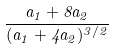<formula> <loc_0><loc_0><loc_500><loc_500>\frac { a _ { 1 } + 8 a _ { 2 } } { ( a _ { 1 } + 4 a _ { 2 } ) ^ { 3 / 2 } }</formula> 